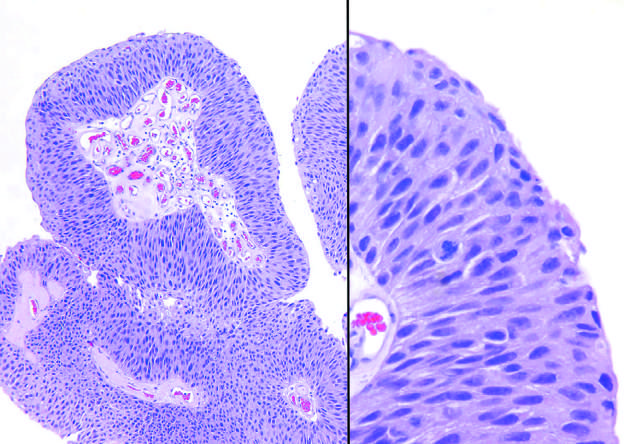what shows slightly irregular nuclei with scattered mitotic figures?
Answer the question using a single word or phrase. Higher magnification 